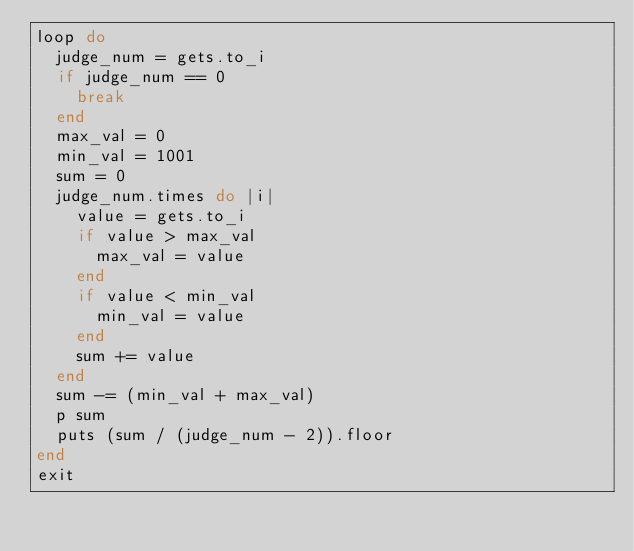Convert code to text. <code><loc_0><loc_0><loc_500><loc_500><_Ruby_>loop do
  judge_num = gets.to_i
  if judge_num == 0
    break
  end
  max_val = 0
  min_val = 1001
  sum = 0
  judge_num.times do |i|
    value = gets.to_i
    if value > max_val
      max_val = value
    end
    if value < min_val
      min_val = value
    end
    sum += value
  end
  sum -= (min_val + max_val)
  p sum
  puts (sum / (judge_num - 2)).floor
end
exit
</code> 